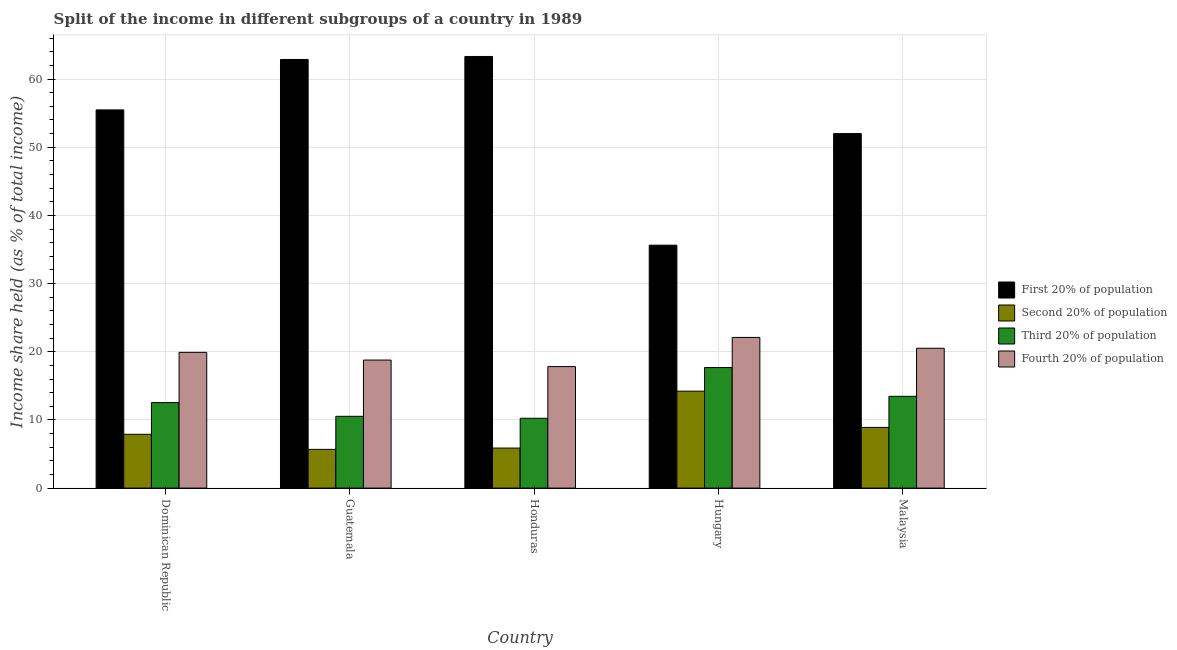Are the number of bars on each tick of the X-axis equal?
Provide a succinct answer. Yes. How many bars are there on the 5th tick from the left?
Offer a very short reply. 4. What is the label of the 1st group of bars from the left?
Offer a terse response. Dominican Republic. What is the share of the income held by second 20% of the population in Dominican Republic?
Your answer should be compact. 7.89. Across all countries, what is the maximum share of the income held by first 20% of the population?
Give a very brief answer. 63.31. Across all countries, what is the minimum share of the income held by third 20% of the population?
Offer a very short reply. 10.24. In which country was the share of the income held by first 20% of the population maximum?
Your response must be concise. Honduras. In which country was the share of the income held by first 20% of the population minimum?
Keep it short and to the point. Hungary. What is the total share of the income held by second 20% of the population in the graph?
Your answer should be compact. 42.56. What is the difference between the share of the income held by fourth 20% of the population in Honduras and that in Malaysia?
Provide a short and direct response. -2.69. What is the difference between the share of the income held by fourth 20% of the population in Malaysia and the share of the income held by first 20% of the population in Guatemala?
Offer a terse response. -42.36. What is the average share of the income held by third 20% of the population per country?
Your response must be concise. 12.89. What is the difference between the share of the income held by third 20% of the population and share of the income held by first 20% of the population in Dominican Republic?
Your answer should be compact. -42.93. What is the ratio of the share of the income held by second 20% of the population in Dominican Republic to that in Hungary?
Ensure brevity in your answer.  0.55. What is the difference between the highest and the second highest share of the income held by second 20% of the population?
Provide a short and direct response. 5.32. What is the difference between the highest and the lowest share of the income held by first 20% of the population?
Ensure brevity in your answer.  27.68. Is it the case that in every country, the sum of the share of the income held by third 20% of the population and share of the income held by second 20% of the population is greater than the sum of share of the income held by first 20% of the population and share of the income held by fourth 20% of the population?
Your response must be concise. No. What does the 4th bar from the left in Hungary represents?
Provide a succinct answer. Fourth 20% of population. What does the 2nd bar from the right in Dominican Republic represents?
Keep it short and to the point. Third 20% of population. Are all the bars in the graph horizontal?
Give a very brief answer. No. What is the difference between two consecutive major ticks on the Y-axis?
Give a very brief answer. 10. Does the graph contain grids?
Your answer should be very brief. Yes. How many legend labels are there?
Make the answer very short. 4. What is the title of the graph?
Your answer should be very brief. Split of the income in different subgroups of a country in 1989. What is the label or title of the X-axis?
Provide a succinct answer. Country. What is the label or title of the Y-axis?
Your answer should be very brief. Income share held (as % of total income). What is the Income share held (as % of total income) in First 20% of population in Dominican Republic?
Offer a very short reply. 55.47. What is the Income share held (as % of total income) of Second 20% of population in Dominican Republic?
Provide a short and direct response. 7.89. What is the Income share held (as % of total income) of Third 20% of population in Dominican Republic?
Make the answer very short. 12.54. What is the Income share held (as % of total income) in Fourth 20% of population in Dominican Republic?
Your answer should be compact. 19.91. What is the Income share held (as % of total income) in First 20% of population in Guatemala?
Your response must be concise. 62.87. What is the Income share held (as % of total income) in Second 20% of population in Guatemala?
Make the answer very short. 5.68. What is the Income share held (as % of total income) of Third 20% of population in Guatemala?
Offer a very short reply. 10.53. What is the Income share held (as % of total income) in Fourth 20% of population in Guatemala?
Provide a short and direct response. 18.78. What is the Income share held (as % of total income) in First 20% of population in Honduras?
Ensure brevity in your answer.  63.31. What is the Income share held (as % of total income) of Second 20% of population in Honduras?
Your response must be concise. 5.87. What is the Income share held (as % of total income) of Third 20% of population in Honduras?
Your response must be concise. 10.24. What is the Income share held (as % of total income) in Fourth 20% of population in Honduras?
Keep it short and to the point. 17.82. What is the Income share held (as % of total income) of First 20% of population in Hungary?
Offer a very short reply. 35.63. What is the Income share held (as % of total income) in Second 20% of population in Hungary?
Your answer should be compact. 14.22. What is the Income share held (as % of total income) in Third 20% of population in Hungary?
Give a very brief answer. 17.68. What is the Income share held (as % of total income) of Fourth 20% of population in Hungary?
Your answer should be compact. 22.1. What is the Income share held (as % of total income) of Second 20% of population in Malaysia?
Keep it short and to the point. 8.9. What is the Income share held (as % of total income) in Third 20% of population in Malaysia?
Your answer should be very brief. 13.46. What is the Income share held (as % of total income) of Fourth 20% of population in Malaysia?
Keep it short and to the point. 20.51. Across all countries, what is the maximum Income share held (as % of total income) in First 20% of population?
Make the answer very short. 63.31. Across all countries, what is the maximum Income share held (as % of total income) in Second 20% of population?
Your response must be concise. 14.22. Across all countries, what is the maximum Income share held (as % of total income) of Third 20% of population?
Provide a short and direct response. 17.68. Across all countries, what is the maximum Income share held (as % of total income) in Fourth 20% of population?
Give a very brief answer. 22.1. Across all countries, what is the minimum Income share held (as % of total income) in First 20% of population?
Provide a succinct answer. 35.63. Across all countries, what is the minimum Income share held (as % of total income) of Second 20% of population?
Provide a short and direct response. 5.68. Across all countries, what is the minimum Income share held (as % of total income) in Third 20% of population?
Offer a very short reply. 10.24. Across all countries, what is the minimum Income share held (as % of total income) in Fourth 20% of population?
Give a very brief answer. 17.82. What is the total Income share held (as % of total income) of First 20% of population in the graph?
Make the answer very short. 269.28. What is the total Income share held (as % of total income) in Second 20% of population in the graph?
Your answer should be compact. 42.56. What is the total Income share held (as % of total income) of Third 20% of population in the graph?
Your response must be concise. 64.45. What is the total Income share held (as % of total income) of Fourth 20% of population in the graph?
Give a very brief answer. 99.12. What is the difference between the Income share held (as % of total income) of First 20% of population in Dominican Republic and that in Guatemala?
Your response must be concise. -7.4. What is the difference between the Income share held (as % of total income) in Second 20% of population in Dominican Republic and that in Guatemala?
Your answer should be compact. 2.21. What is the difference between the Income share held (as % of total income) of Third 20% of population in Dominican Republic and that in Guatemala?
Your answer should be compact. 2.01. What is the difference between the Income share held (as % of total income) of Fourth 20% of population in Dominican Republic and that in Guatemala?
Provide a succinct answer. 1.13. What is the difference between the Income share held (as % of total income) of First 20% of population in Dominican Republic and that in Honduras?
Your response must be concise. -7.84. What is the difference between the Income share held (as % of total income) in Second 20% of population in Dominican Republic and that in Honduras?
Your answer should be very brief. 2.02. What is the difference between the Income share held (as % of total income) in Fourth 20% of population in Dominican Republic and that in Honduras?
Your answer should be compact. 2.09. What is the difference between the Income share held (as % of total income) of First 20% of population in Dominican Republic and that in Hungary?
Keep it short and to the point. 19.84. What is the difference between the Income share held (as % of total income) in Second 20% of population in Dominican Republic and that in Hungary?
Your response must be concise. -6.33. What is the difference between the Income share held (as % of total income) in Third 20% of population in Dominican Republic and that in Hungary?
Provide a succinct answer. -5.14. What is the difference between the Income share held (as % of total income) of Fourth 20% of population in Dominican Republic and that in Hungary?
Offer a terse response. -2.19. What is the difference between the Income share held (as % of total income) in First 20% of population in Dominican Republic and that in Malaysia?
Your answer should be very brief. 3.47. What is the difference between the Income share held (as % of total income) in Second 20% of population in Dominican Republic and that in Malaysia?
Your answer should be compact. -1.01. What is the difference between the Income share held (as % of total income) in Third 20% of population in Dominican Republic and that in Malaysia?
Your answer should be compact. -0.92. What is the difference between the Income share held (as % of total income) of First 20% of population in Guatemala and that in Honduras?
Offer a very short reply. -0.44. What is the difference between the Income share held (as % of total income) in Second 20% of population in Guatemala and that in Honduras?
Ensure brevity in your answer.  -0.19. What is the difference between the Income share held (as % of total income) in Third 20% of population in Guatemala and that in Honduras?
Your answer should be very brief. 0.29. What is the difference between the Income share held (as % of total income) of First 20% of population in Guatemala and that in Hungary?
Offer a terse response. 27.24. What is the difference between the Income share held (as % of total income) of Second 20% of population in Guatemala and that in Hungary?
Your response must be concise. -8.54. What is the difference between the Income share held (as % of total income) in Third 20% of population in Guatemala and that in Hungary?
Your answer should be very brief. -7.15. What is the difference between the Income share held (as % of total income) in Fourth 20% of population in Guatemala and that in Hungary?
Your answer should be very brief. -3.32. What is the difference between the Income share held (as % of total income) of First 20% of population in Guatemala and that in Malaysia?
Offer a very short reply. 10.87. What is the difference between the Income share held (as % of total income) in Second 20% of population in Guatemala and that in Malaysia?
Ensure brevity in your answer.  -3.22. What is the difference between the Income share held (as % of total income) in Third 20% of population in Guatemala and that in Malaysia?
Your answer should be very brief. -2.93. What is the difference between the Income share held (as % of total income) in Fourth 20% of population in Guatemala and that in Malaysia?
Provide a short and direct response. -1.73. What is the difference between the Income share held (as % of total income) of First 20% of population in Honduras and that in Hungary?
Give a very brief answer. 27.68. What is the difference between the Income share held (as % of total income) in Second 20% of population in Honduras and that in Hungary?
Offer a terse response. -8.35. What is the difference between the Income share held (as % of total income) of Third 20% of population in Honduras and that in Hungary?
Provide a short and direct response. -7.44. What is the difference between the Income share held (as % of total income) of Fourth 20% of population in Honduras and that in Hungary?
Your response must be concise. -4.28. What is the difference between the Income share held (as % of total income) of First 20% of population in Honduras and that in Malaysia?
Your answer should be very brief. 11.31. What is the difference between the Income share held (as % of total income) in Second 20% of population in Honduras and that in Malaysia?
Your answer should be very brief. -3.03. What is the difference between the Income share held (as % of total income) of Third 20% of population in Honduras and that in Malaysia?
Provide a succinct answer. -3.22. What is the difference between the Income share held (as % of total income) of Fourth 20% of population in Honduras and that in Malaysia?
Your answer should be very brief. -2.69. What is the difference between the Income share held (as % of total income) in First 20% of population in Hungary and that in Malaysia?
Your answer should be compact. -16.37. What is the difference between the Income share held (as % of total income) of Second 20% of population in Hungary and that in Malaysia?
Ensure brevity in your answer.  5.32. What is the difference between the Income share held (as % of total income) in Third 20% of population in Hungary and that in Malaysia?
Provide a short and direct response. 4.22. What is the difference between the Income share held (as % of total income) of Fourth 20% of population in Hungary and that in Malaysia?
Make the answer very short. 1.59. What is the difference between the Income share held (as % of total income) in First 20% of population in Dominican Republic and the Income share held (as % of total income) in Second 20% of population in Guatemala?
Your answer should be very brief. 49.79. What is the difference between the Income share held (as % of total income) of First 20% of population in Dominican Republic and the Income share held (as % of total income) of Third 20% of population in Guatemala?
Your answer should be very brief. 44.94. What is the difference between the Income share held (as % of total income) in First 20% of population in Dominican Republic and the Income share held (as % of total income) in Fourth 20% of population in Guatemala?
Ensure brevity in your answer.  36.69. What is the difference between the Income share held (as % of total income) in Second 20% of population in Dominican Republic and the Income share held (as % of total income) in Third 20% of population in Guatemala?
Keep it short and to the point. -2.64. What is the difference between the Income share held (as % of total income) of Second 20% of population in Dominican Republic and the Income share held (as % of total income) of Fourth 20% of population in Guatemala?
Provide a succinct answer. -10.89. What is the difference between the Income share held (as % of total income) in Third 20% of population in Dominican Republic and the Income share held (as % of total income) in Fourth 20% of population in Guatemala?
Offer a terse response. -6.24. What is the difference between the Income share held (as % of total income) in First 20% of population in Dominican Republic and the Income share held (as % of total income) in Second 20% of population in Honduras?
Keep it short and to the point. 49.6. What is the difference between the Income share held (as % of total income) in First 20% of population in Dominican Republic and the Income share held (as % of total income) in Third 20% of population in Honduras?
Provide a short and direct response. 45.23. What is the difference between the Income share held (as % of total income) in First 20% of population in Dominican Republic and the Income share held (as % of total income) in Fourth 20% of population in Honduras?
Your answer should be very brief. 37.65. What is the difference between the Income share held (as % of total income) in Second 20% of population in Dominican Republic and the Income share held (as % of total income) in Third 20% of population in Honduras?
Provide a succinct answer. -2.35. What is the difference between the Income share held (as % of total income) of Second 20% of population in Dominican Republic and the Income share held (as % of total income) of Fourth 20% of population in Honduras?
Your response must be concise. -9.93. What is the difference between the Income share held (as % of total income) of Third 20% of population in Dominican Republic and the Income share held (as % of total income) of Fourth 20% of population in Honduras?
Ensure brevity in your answer.  -5.28. What is the difference between the Income share held (as % of total income) of First 20% of population in Dominican Republic and the Income share held (as % of total income) of Second 20% of population in Hungary?
Offer a very short reply. 41.25. What is the difference between the Income share held (as % of total income) in First 20% of population in Dominican Republic and the Income share held (as % of total income) in Third 20% of population in Hungary?
Offer a terse response. 37.79. What is the difference between the Income share held (as % of total income) of First 20% of population in Dominican Republic and the Income share held (as % of total income) of Fourth 20% of population in Hungary?
Provide a succinct answer. 33.37. What is the difference between the Income share held (as % of total income) of Second 20% of population in Dominican Republic and the Income share held (as % of total income) of Third 20% of population in Hungary?
Your response must be concise. -9.79. What is the difference between the Income share held (as % of total income) of Second 20% of population in Dominican Republic and the Income share held (as % of total income) of Fourth 20% of population in Hungary?
Keep it short and to the point. -14.21. What is the difference between the Income share held (as % of total income) of Third 20% of population in Dominican Republic and the Income share held (as % of total income) of Fourth 20% of population in Hungary?
Give a very brief answer. -9.56. What is the difference between the Income share held (as % of total income) in First 20% of population in Dominican Republic and the Income share held (as % of total income) in Second 20% of population in Malaysia?
Ensure brevity in your answer.  46.57. What is the difference between the Income share held (as % of total income) in First 20% of population in Dominican Republic and the Income share held (as % of total income) in Third 20% of population in Malaysia?
Keep it short and to the point. 42.01. What is the difference between the Income share held (as % of total income) of First 20% of population in Dominican Republic and the Income share held (as % of total income) of Fourth 20% of population in Malaysia?
Provide a short and direct response. 34.96. What is the difference between the Income share held (as % of total income) of Second 20% of population in Dominican Republic and the Income share held (as % of total income) of Third 20% of population in Malaysia?
Offer a very short reply. -5.57. What is the difference between the Income share held (as % of total income) in Second 20% of population in Dominican Republic and the Income share held (as % of total income) in Fourth 20% of population in Malaysia?
Keep it short and to the point. -12.62. What is the difference between the Income share held (as % of total income) in Third 20% of population in Dominican Republic and the Income share held (as % of total income) in Fourth 20% of population in Malaysia?
Give a very brief answer. -7.97. What is the difference between the Income share held (as % of total income) of First 20% of population in Guatemala and the Income share held (as % of total income) of Second 20% of population in Honduras?
Make the answer very short. 57. What is the difference between the Income share held (as % of total income) of First 20% of population in Guatemala and the Income share held (as % of total income) of Third 20% of population in Honduras?
Offer a terse response. 52.63. What is the difference between the Income share held (as % of total income) in First 20% of population in Guatemala and the Income share held (as % of total income) in Fourth 20% of population in Honduras?
Your response must be concise. 45.05. What is the difference between the Income share held (as % of total income) in Second 20% of population in Guatemala and the Income share held (as % of total income) in Third 20% of population in Honduras?
Offer a terse response. -4.56. What is the difference between the Income share held (as % of total income) of Second 20% of population in Guatemala and the Income share held (as % of total income) of Fourth 20% of population in Honduras?
Ensure brevity in your answer.  -12.14. What is the difference between the Income share held (as % of total income) in Third 20% of population in Guatemala and the Income share held (as % of total income) in Fourth 20% of population in Honduras?
Your response must be concise. -7.29. What is the difference between the Income share held (as % of total income) of First 20% of population in Guatemala and the Income share held (as % of total income) of Second 20% of population in Hungary?
Ensure brevity in your answer.  48.65. What is the difference between the Income share held (as % of total income) of First 20% of population in Guatemala and the Income share held (as % of total income) of Third 20% of population in Hungary?
Provide a short and direct response. 45.19. What is the difference between the Income share held (as % of total income) in First 20% of population in Guatemala and the Income share held (as % of total income) in Fourth 20% of population in Hungary?
Provide a short and direct response. 40.77. What is the difference between the Income share held (as % of total income) of Second 20% of population in Guatemala and the Income share held (as % of total income) of Fourth 20% of population in Hungary?
Offer a very short reply. -16.42. What is the difference between the Income share held (as % of total income) in Third 20% of population in Guatemala and the Income share held (as % of total income) in Fourth 20% of population in Hungary?
Give a very brief answer. -11.57. What is the difference between the Income share held (as % of total income) of First 20% of population in Guatemala and the Income share held (as % of total income) of Second 20% of population in Malaysia?
Provide a succinct answer. 53.97. What is the difference between the Income share held (as % of total income) in First 20% of population in Guatemala and the Income share held (as % of total income) in Third 20% of population in Malaysia?
Ensure brevity in your answer.  49.41. What is the difference between the Income share held (as % of total income) in First 20% of population in Guatemala and the Income share held (as % of total income) in Fourth 20% of population in Malaysia?
Keep it short and to the point. 42.36. What is the difference between the Income share held (as % of total income) in Second 20% of population in Guatemala and the Income share held (as % of total income) in Third 20% of population in Malaysia?
Make the answer very short. -7.78. What is the difference between the Income share held (as % of total income) of Second 20% of population in Guatemala and the Income share held (as % of total income) of Fourth 20% of population in Malaysia?
Make the answer very short. -14.83. What is the difference between the Income share held (as % of total income) in Third 20% of population in Guatemala and the Income share held (as % of total income) in Fourth 20% of population in Malaysia?
Offer a very short reply. -9.98. What is the difference between the Income share held (as % of total income) in First 20% of population in Honduras and the Income share held (as % of total income) in Second 20% of population in Hungary?
Ensure brevity in your answer.  49.09. What is the difference between the Income share held (as % of total income) of First 20% of population in Honduras and the Income share held (as % of total income) of Third 20% of population in Hungary?
Make the answer very short. 45.63. What is the difference between the Income share held (as % of total income) in First 20% of population in Honduras and the Income share held (as % of total income) in Fourth 20% of population in Hungary?
Your response must be concise. 41.21. What is the difference between the Income share held (as % of total income) of Second 20% of population in Honduras and the Income share held (as % of total income) of Third 20% of population in Hungary?
Make the answer very short. -11.81. What is the difference between the Income share held (as % of total income) of Second 20% of population in Honduras and the Income share held (as % of total income) of Fourth 20% of population in Hungary?
Ensure brevity in your answer.  -16.23. What is the difference between the Income share held (as % of total income) of Third 20% of population in Honduras and the Income share held (as % of total income) of Fourth 20% of population in Hungary?
Provide a short and direct response. -11.86. What is the difference between the Income share held (as % of total income) of First 20% of population in Honduras and the Income share held (as % of total income) of Second 20% of population in Malaysia?
Give a very brief answer. 54.41. What is the difference between the Income share held (as % of total income) of First 20% of population in Honduras and the Income share held (as % of total income) of Third 20% of population in Malaysia?
Your response must be concise. 49.85. What is the difference between the Income share held (as % of total income) in First 20% of population in Honduras and the Income share held (as % of total income) in Fourth 20% of population in Malaysia?
Your response must be concise. 42.8. What is the difference between the Income share held (as % of total income) of Second 20% of population in Honduras and the Income share held (as % of total income) of Third 20% of population in Malaysia?
Offer a very short reply. -7.59. What is the difference between the Income share held (as % of total income) in Second 20% of population in Honduras and the Income share held (as % of total income) in Fourth 20% of population in Malaysia?
Give a very brief answer. -14.64. What is the difference between the Income share held (as % of total income) of Third 20% of population in Honduras and the Income share held (as % of total income) of Fourth 20% of population in Malaysia?
Offer a terse response. -10.27. What is the difference between the Income share held (as % of total income) in First 20% of population in Hungary and the Income share held (as % of total income) in Second 20% of population in Malaysia?
Offer a terse response. 26.73. What is the difference between the Income share held (as % of total income) of First 20% of population in Hungary and the Income share held (as % of total income) of Third 20% of population in Malaysia?
Your response must be concise. 22.17. What is the difference between the Income share held (as % of total income) in First 20% of population in Hungary and the Income share held (as % of total income) in Fourth 20% of population in Malaysia?
Keep it short and to the point. 15.12. What is the difference between the Income share held (as % of total income) in Second 20% of population in Hungary and the Income share held (as % of total income) in Third 20% of population in Malaysia?
Your response must be concise. 0.76. What is the difference between the Income share held (as % of total income) in Second 20% of population in Hungary and the Income share held (as % of total income) in Fourth 20% of population in Malaysia?
Offer a very short reply. -6.29. What is the difference between the Income share held (as % of total income) of Third 20% of population in Hungary and the Income share held (as % of total income) of Fourth 20% of population in Malaysia?
Make the answer very short. -2.83. What is the average Income share held (as % of total income) of First 20% of population per country?
Your answer should be compact. 53.86. What is the average Income share held (as % of total income) in Second 20% of population per country?
Your response must be concise. 8.51. What is the average Income share held (as % of total income) of Third 20% of population per country?
Your response must be concise. 12.89. What is the average Income share held (as % of total income) in Fourth 20% of population per country?
Your answer should be very brief. 19.82. What is the difference between the Income share held (as % of total income) in First 20% of population and Income share held (as % of total income) in Second 20% of population in Dominican Republic?
Keep it short and to the point. 47.58. What is the difference between the Income share held (as % of total income) of First 20% of population and Income share held (as % of total income) of Third 20% of population in Dominican Republic?
Your answer should be very brief. 42.93. What is the difference between the Income share held (as % of total income) of First 20% of population and Income share held (as % of total income) of Fourth 20% of population in Dominican Republic?
Offer a terse response. 35.56. What is the difference between the Income share held (as % of total income) of Second 20% of population and Income share held (as % of total income) of Third 20% of population in Dominican Republic?
Provide a succinct answer. -4.65. What is the difference between the Income share held (as % of total income) in Second 20% of population and Income share held (as % of total income) in Fourth 20% of population in Dominican Republic?
Ensure brevity in your answer.  -12.02. What is the difference between the Income share held (as % of total income) of Third 20% of population and Income share held (as % of total income) of Fourth 20% of population in Dominican Republic?
Your response must be concise. -7.37. What is the difference between the Income share held (as % of total income) of First 20% of population and Income share held (as % of total income) of Second 20% of population in Guatemala?
Your response must be concise. 57.19. What is the difference between the Income share held (as % of total income) of First 20% of population and Income share held (as % of total income) of Third 20% of population in Guatemala?
Keep it short and to the point. 52.34. What is the difference between the Income share held (as % of total income) of First 20% of population and Income share held (as % of total income) of Fourth 20% of population in Guatemala?
Ensure brevity in your answer.  44.09. What is the difference between the Income share held (as % of total income) of Second 20% of population and Income share held (as % of total income) of Third 20% of population in Guatemala?
Ensure brevity in your answer.  -4.85. What is the difference between the Income share held (as % of total income) of Second 20% of population and Income share held (as % of total income) of Fourth 20% of population in Guatemala?
Make the answer very short. -13.1. What is the difference between the Income share held (as % of total income) of Third 20% of population and Income share held (as % of total income) of Fourth 20% of population in Guatemala?
Keep it short and to the point. -8.25. What is the difference between the Income share held (as % of total income) in First 20% of population and Income share held (as % of total income) in Second 20% of population in Honduras?
Make the answer very short. 57.44. What is the difference between the Income share held (as % of total income) in First 20% of population and Income share held (as % of total income) in Third 20% of population in Honduras?
Offer a terse response. 53.07. What is the difference between the Income share held (as % of total income) in First 20% of population and Income share held (as % of total income) in Fourth 20% of population in Honduras?
Make the answer very short. 45.49. What is the difference between the Income share held (as % of total income) of Second 20% of population and Income share held (as % of total income) of Third 20% of population in Honduras?
Ensure brevity in your answer.  -4.37. What is the difference between the Income share held (as % of total income) of Second 20% of population and Income share held (as % of total income) of Fourth 20% of population in Honduras?
Provide a succinct answer. -11.95. What is the difference between the Income share held (as % of total income) of Third 20% of population and Income share held (as % of total income) of Fourth 20% of population in Honduras?
Your answer should be very brief. -7.58. What is the difference between the Income share held (as % of total income) in First 20% of population and Income share held (as % of total income) in Second 20% of population in Hungary?
Provide a succinct answer. 21.41. What is the difference between the Income share held (as % of total income) of First 20% of population and Income share held (as % of total income) of Third 20% of population in Hungary?
Offer a terse response. 17.95. What is the difference between the Income share held (as % of total income) of First 20% of population and Income share held (as % of total income) of Fourth 20% of population in Hungary?
Give a very brief answer. 13.53. What is the difference between the Income share held (as % of total income) of Second 20% of population and Income share held (as % of total income) of Third 20% of population in Hungary?
Your response must be concise. -3.46. What is the difference between the Income share held (as % of total income) in Second 20% of population and Income share held (as % of total income) in Fourth 20% of population in Hungary?
Your answer should be very brief. -7.88. What is the difference between the Income share held (as % of total income) of Third 20% of population and Income share held (as % of total income) of Fourth 20% of population in Hungary?
Offer a terse response. -4.42. What is the difference between the Income share held (as % of total income) in First 20% of population and Income share held (as % of total income) in Second 20% of population in Malaysia?
Offer a very short reply. 43.1. What is the difference between the Income share held (as % of total income) of First 20% of population and Income share held (as % of total income) of Third 20% of population in Malaysia?
Your answer should be compact. 38.54. What is the difference between the Income share held (as % of total income) in First 20% of population and Income share held (as % of total income) in Fourth 20% of population in Malaysia?
Offer a very short reply. 31.49. What is the difference between the Income share held (as % of total income) in Second 20% of population and Income share held (as % of total income) in Third 20% of population in Malaysia?
Give a very brief answer. -4.56. What is the difference between the Income share held (as % of total income) in Second 20% of population and Income share held (as % of total income) in Fourth 20% of population in Malaysia?
Offer a very short reply. -11.61. What is the difference between the Income share held (as % of total income) of Third 20% of population and Income share held (as % of total income) of Fourth 20% of population in Malaysia?
Your response must be concise. -7.05. What is the ratio of the Income share held (as % of total income) in First 20% of population in Dominican Republic to that in Guatemala?
Give a very brief answer. 0.88. What is the ratio of the Income share held (as % of total income) in Second 20% of population in Dominican Republic to that in Guatemala?
Give a very brief answer. 1.39. What is the ratio of the Income share held (as % of total income) of Third 20% of population in Dominican Republic to that in Guatemala?
Your answer should be compact. 1.19. What is the ratio of the Income share held (as % of total income) in Fourth 20% of population in Dominican Republic to that in Guatemala?
Ensure brevity in your answer.  1.06. What is the ratio of the Income share held (as % of total income) of First 20% of population in Dominican Republic to that in Honduras?
Provide a succinct answer. 0.88. What is the ratio of the Income share held (as % of total income) of Second 20% of population in Dominican Republic to that in Honduras?
Provide a succinct answer. 1.34. What is the ratio of the Income share held (as % of total income) in Third 20% of population in Dominican Republic to that in Honduras?
Your response must be concise. 1.22. What is the ratio of the Income share held (as % of total income) in Fourth 20% of population in Dominican Republic to that in Honduras?
Provide a short and direct response. 1.12. What is the ratio of the Income share held (as % of total income) in First 20% of population in Dominican Republic to that in Hungary?
Provide a short and direct response. 1.56. What is the ratio of the Income share held (as % of total income) of Second 20% of population in Dominican Republic to that in Hungary?
Provide a short and direct response. 0.55. What is the ratio of the Income share held (as % of total income) in Third 20% of population in Dominican Republic to that in Hungary?
Make the answer very short. 0.71. What is the ratio of the Income share held (as % of total income) of Fourth 20% of population in Dominican Republic to that in Hungary?
Offer a very short reply. 0.9. What is the ratio of the Income share held (as % of total income) of First 20% of population in Dominican Republic to that in Malaysia?
Offer a terse response. 1.07. What is the ratio of the Income share held (as % of total income) in Second 20% of population in Dominican Republic to that in Malaysia?
Your response must be concise. 0.89. What is the ratio of the Income share held (as % of total income) in Third 20% of population in Dominican Republic to that in Malaysia?
Your response must be concise. 0.93. What is the ratio of the Income share held (as % of total income) in Fourth 20% of population in Dominican Republic to that in Malaysia?
Give a very brief answer. 0.97. What is the ratio of the Income share held (as % of total income) in Second 20% of population in Guatemala to that in Honduras?
Keep it short and to the point. 0.97. What is the ratio of the Income share held (as % of total income) of Third 20% of population in Guatemala to that in Honduras?
Make the answer very short. 1.03. What is the ratio of the Income share held (as % of total income) in Fourth 20% of population in Guatemala to that in Honduras?
Ensure brevity in your answer.  1.05. What is the ratio of the Income share held (as % of total income) of First 20% of population in Guatemala to that in Hungary?
Your answer should be very brief. 1.76. What is the ratio of the Income share held (as % of total income) in Second 20% of population in Guatemala to that in Hungary?
Provide a succinct answer. 0.4. What is the ratio of the Income share held (as % of total income) in Third 20% of population in Guatemala to that in Hungary?
Provide a succinct answer. 0.6. What is the ratio of the Income share held (as % of total income) in Fourth 20% of population in Guatemala to that in Hungary?
Your response must be concise. 0.85. What is the ratio of the Income share held (as % of total income) of First 20% of population in Guatemala to that in Malaysia?
Your answer should be compact. 1.21. What is the ratio of the Income share held (as % of total income) in Second 20% of population in Guatemala to that in Malaysia?
Offer a terse response. 0.64. What is the ratio of the Income share held (as % of total income) in Third 20% of population in Guatemala to that in Malaysia?
Offer a terse response. 0.78. What is the ratio of the Income share held (as % of total income) in Fourth 20% of population in Guatemala to that in Malaysia?
Offer a very short reply. 0.92. What is the ratio of the Income share held (as % of total income) in First 20% of population in Honduras to that in Hungary?
Ensure brevity in your answer.  1.78. What is the ratio of the Income share held (as % of total income) in Second 20% of population in Honduras to that in Hungary?
Give a very brief answer. 0.41. What is the ratio of the Income share held (as % of total income) of Third 20% of population in Honduras to that in Hungary?
Offer a terse response. 0.58. What is the ratio of the Income share held (as % of total income) in Fourth 20% of population in Honduras to that in Hungary?
Offer a terse response. 0.81. What is the ratio of the Income share held (as % of total income) of First 20% of population in Honduras to that in Malaysia?
Your response must be concise. 1.22. What is the ratio of the Income share held (as % of total income) of Second 20% of population in Honduras to that in Malaysia?
Your answer should be very brief. 0.66. What is the ratio of the Income share held (as % of total income) in Third 20% of population in Honduras to that in Malaysia?
Provide a short and direct response. 0.76. What is the ratio of the Income share held (as % of total income) of Fourth 20% of population in Honduras to that in Malaysia?
Ensure brevity in your answer.  0.87. What is the ratio of the Income share held (as % of total income) in First 20% of population in Hungary to that in Malaysia?
Your answer should be very brief. 0.69. What is the ratio of the Income share held (as % of total income) in Second 20% of population in Hungary to that in Malaysia?
Give a very brief answer. 1.6. What is the ratio of the Income share held (as % of total income) of Third 20% of population in Hungary to that in Malaysia?
Your response must be concise. 1.31. What is the ratio of the Income share held (as % of total income) in Fourth 20% of population in Hungary to that in Malaysia?
Provide a succinct answer. 1.08. What is the difference between the highest and the second highest Income share held (as % of total income) in First 20% of population?
Provide a short and direct response. 0.44. What is the difference between the highest and the second highest Income share held (as % of total income) in Second 20% of population?
Offer a very short reply. 5.32. What is the difference between the highest and the second highest Income share held (as % of total income) of Third 20% of population?
Your answer should be very brief. 4.22. What is the difference between the highest and the second highest Income share held (as % of total income) in Fourth 20% of population?
Give a very brief answer. 1.59. What is the difference between the highest and the lowest Income share held (as % of total income) of First 20% of population?
Offer a terse response. 27.68. What is the difference between the highest and the lowest Income share held (as % of total income) in Second 20% of population?
Provide a short and direct response. 8.54. What is the difference between the highest and the lowest Income share held (as % of total income) of Third 20% of population?
Provide a short and direct response. 7.44. What is the difference between the highest and the lowest Income share held (as % of total income) in Fourth 20% of population?
Provide a short and direct response. 4.28. 